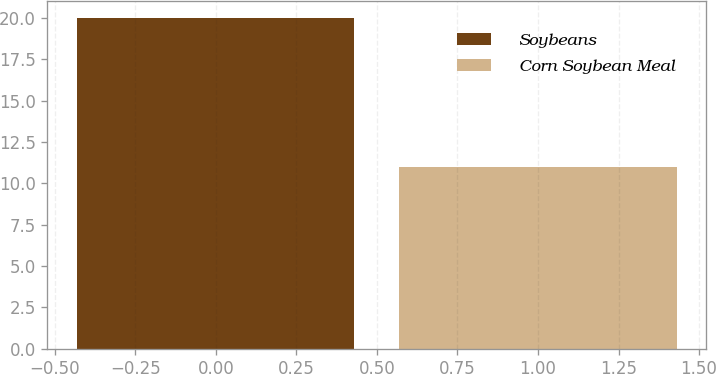<chart> <loc_0><loc_0><loc_500><loc_500><bar_chart><fcel>Soybeans<fcel>Corn Soybean Meal<nl><fcel>20<fcel>11<nl></chart> 